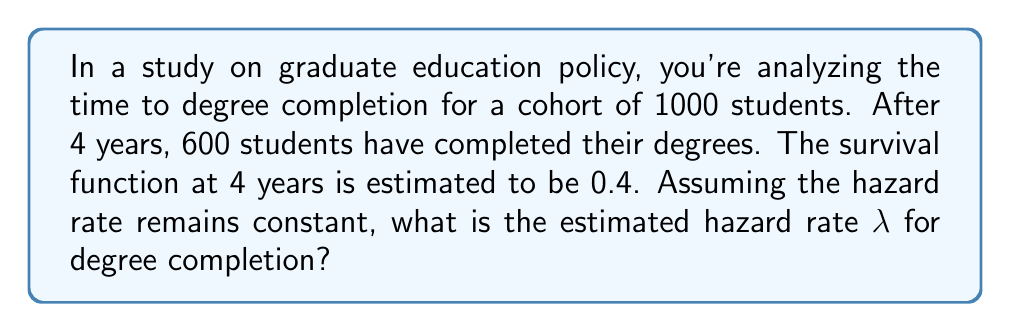Help me with this question. Let's approach this step-by-step using survival analysis concepts:

1) The survival function S(t) represents the probability of "surviving" (not completing the degree) beyond time t.

2) We're given that S(4) = 0.4

3) For a constant hazard rate λ, the survival function is given by:

   $$S(t) = e^{-λt}$$

4) Substituting our known values:

   $$0.4 = e^{-4λ}$$

5) Taking the natural log of both sides:

   $$\ln(0.4) = -4λ$$

6) Solve for λ:

   $$-4λ = \ln(0.4)$$
   $$λ = -\frac{\ln(0.4)}{4}$$

7) Calculate the value:

   $$λ = -\frac{\ln(0.4)}{4} \approx 0.2301$$

Therefore, the estimated hazard rate λ is approximately 0.2301 per year.
Answer: 0.2301 per year 